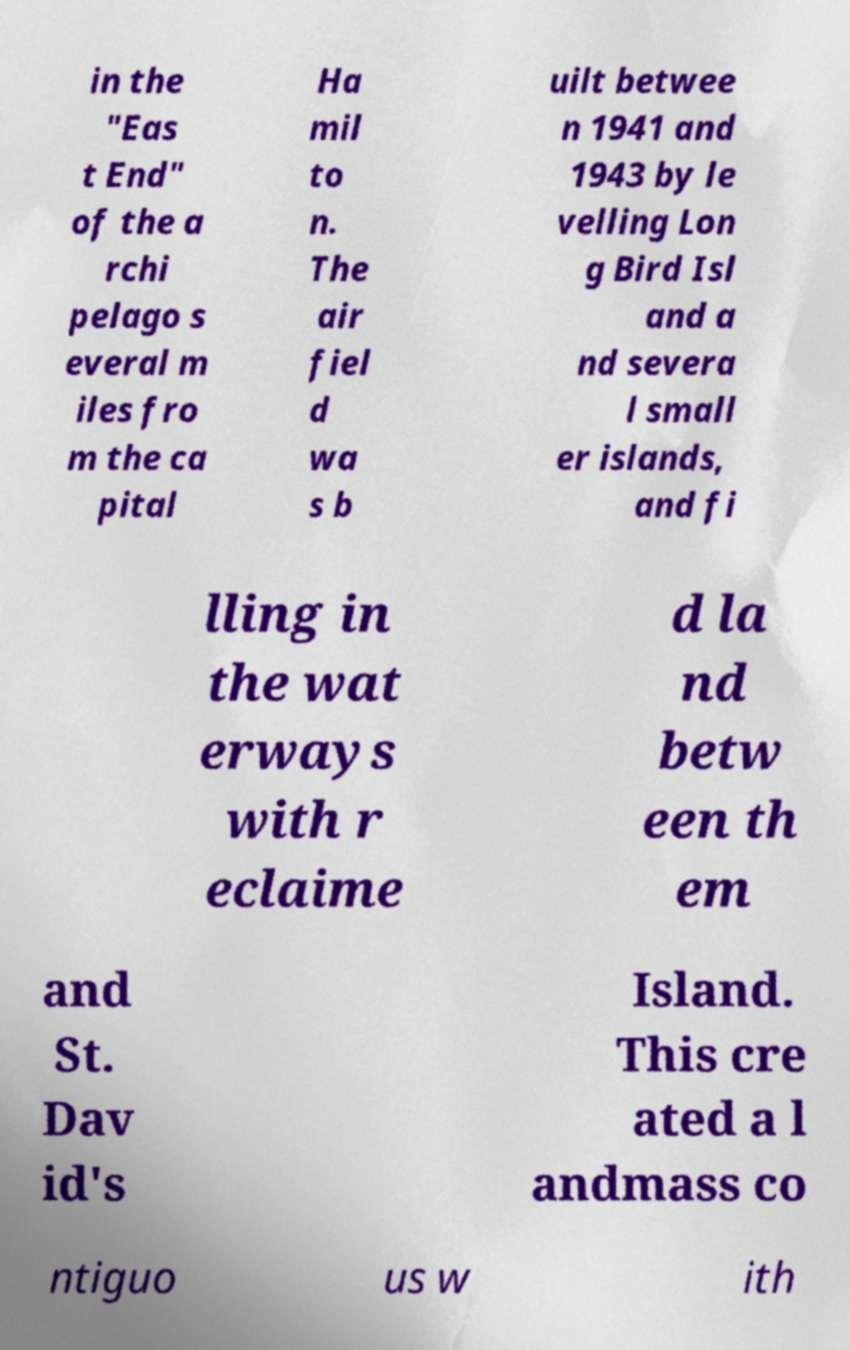There's text embedded in this image that I need extracted. Can you transcribe it verbatim? in the "Eas t End" of the a rchi pelago s everal m iles fro m the ca pital Ha mil to n. The air fiel d wa s b uilt betwee n 1941 and 1943 by le velling Lon g Bird Isl and a nd severa l small er islands, and fi lling in the wat erways with r eclaime d la nd betw een th em and St. Dav id's Island. This cre ated a l andmass co ntiguo us w ith 